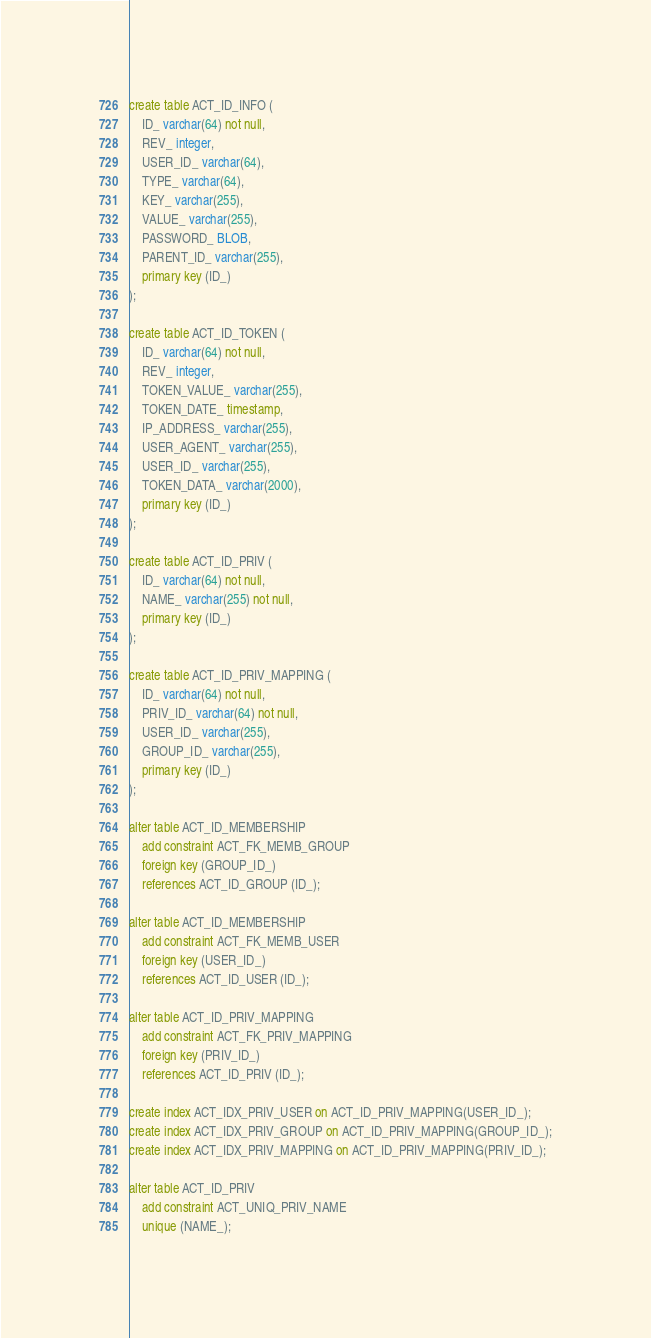<code> <loc_0><loc_0><loc_500><loc_500><_SQL_>create table ACT_ID_INFO (
    ID_ varchar(64) not null,
    REV_ integer,
    USER_ID_ varchar(64),
    TYPE_ varchar(64),
    KEY_ varchar(255),
    VALUE_ varchar(255),
    PASSWORD_ BLOB,
    PARENT_ID_ varchar(255),
    primary key (ID_)
);

create table ACT_ID_TOKEN (
    ID_ varchar(64) not null,
    REV_ integer,
    TOKEN_VALUE_ varchar(255),
    TOKEN_DATE_ timestamp,
    IP_ADDRESS_ varchar(255),
    USER_AGENT_ varchar(255),
    USER_ID_ varchar(255),
    TOKEN_DATA_ varchar(2000),
    primary key (ID_)
);

create table ACT_ID_PRIV (
    ID_ varchar(64) not null,
    NAME_ varchar(255) not null,
    primary key (ID_)
);

create table ACT_ID_PRIV_MAPPING (
    ID_ varchar(64) not null,
    PRIV_ID_ varchar(64) not null,
    USER_ID_ varchar(255),
    GROUP_ID_ varchar(255),
    primary key (ID_)
);

alter table ACT_ID_MEMBERSHIP
    add constraint ACT_FK_MEMB_GROUP
    foreign key (GROUP_ID_)
    references ACT_ID_GROUP (ID_);

alter table ACT_ID_MEMBERSHIP
    add constraint ACT_FK_MEMB_USER
    foreign key (USER_ID_)
    references ACT_ID_USER (ID_);

alter table ACT_ID_PRIV_MAPPING
    add constraint ACT_FK_PRIV_MAPPING
    foreign key (PRIV_ID_)
    references ACT_ID_PRIV (ID_);

create index ACT_IDX_PRIV_USER on ACT_ID_PRIV_MAPPING(USER_ID_);
create index ACT_IDX_PRIV_GROUP on ACT_ID_PRIV_MAPPING(GROUP_ID_);
create index ACT_IDX_PRIV_MAPPING on ACT_ID_PRIV_MAPPING(PRIV_ID_);

alter table ACT_ID_PRIV
    add constraint ACT_UNIQ_PRIV_NAME
    unique (NAME_);
</code> 